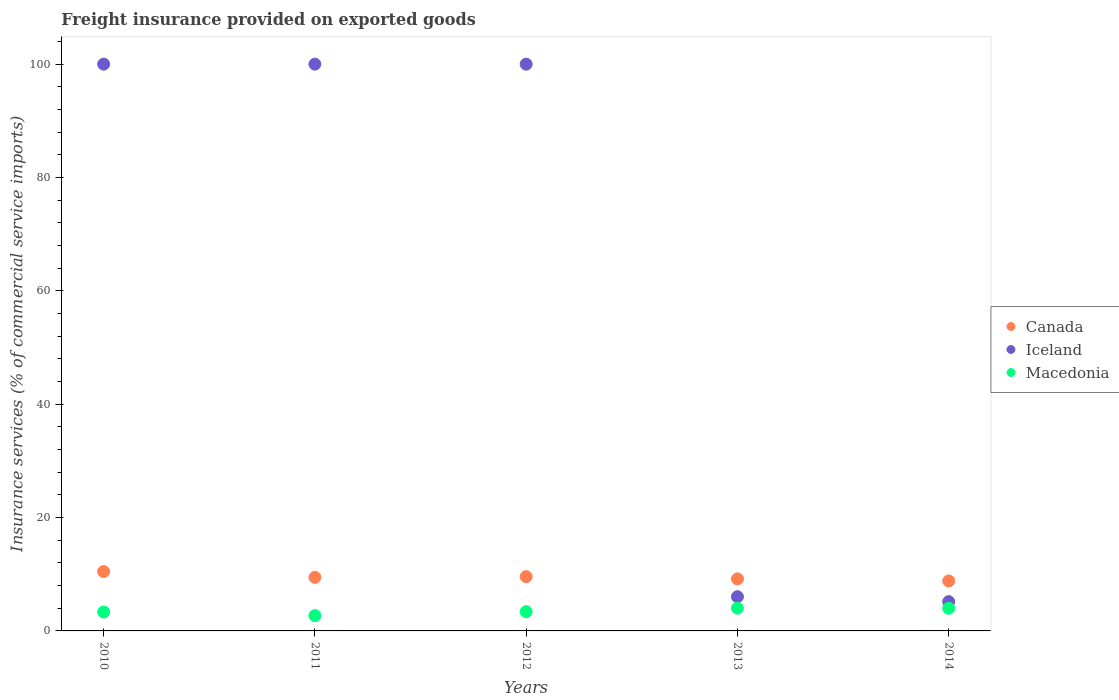What is the freight insurance provided on exported goods in Canada in 2013?
Your answer should be compact. 9.18. Across all years, what is the maximum freight insurance provided on exported goods in Iceland?
Give a very brief answer. 100. Across all years, what is the minimum freight insurance provided on exported goods in Canada?
Give a very brief answer. 8.82. In which year was the freight insurance provided on exported goods in Canada minimum?
Offer a very short reply. 2014. What is the total freight insurance provided on exported goods in Canada in the graph?
Ensure brevity in your answer.  47.5. What is the difference between the freight insurance provided on exported goods in Macedonia in 2012 and that in 2013?
Ensure brevity in your answer.  -0.62. What is the difference between the freight insurance provided on exported goods in Iceland in 2013 and the freight insurance provided on exported goods in Macedonia in 2014?
Give a very brief answer. 2.03. What is the average freight insurance provided on exported goods in Macedonia per year?
Ensure brevity in your answer.  3.49. In the year 2013, what is the difference between the freight insurance provided on exported goods in Canada and freight insurance provided on exported goods in Macedonia?
Ensure brevity in your answer.  5.17. What is the ratio of the freight insurance provided on exported goods in Macedonia in 2011 to that in 2012?
Make the answer very short. 0.79. Is the freight insurance provided on exported goods in Canada in 2011 less than that in 2013?
Keep it short and to the point. No. Is the difference between the freight insurance provided on exported goods in Canada in 2012 and 2013 greater than the difference between the freight insurance provided on exported goods in Macedonia in 2012 and 2013?
Make the answer very short. Yes. What is the difference between the highest and the second highest freight insurance provided on exported goods in Canada?
Your answer should be compact. 0.89. What is the difference between the highest and the lowest freight insurance provided on exported goods in Iceland?
Offer a terse response. 94.83. In how many years, is the freight insurance provided on exported goods in Macedonia greater than the average freight insurance provided on exported goods in Macedonia taken over all years?
Provide a short and direct response. 2. Is it the case that in every year, the sum of the freight insurance provided on exported goods in Iceland and freight insurance provided on exported goods in Canada  is greater than the freight insurance provided on exported goods in Macedonia?
Your answer should be very brief. Yes. Is the freight insurance provided on exported goods in Canada strictly less than the freight insurance provided on exported goods in Iceland over the years?
Offer a terse response. No. How many dotlines are there?
Provide a short and direct response. 3. Are the values on the major ticks of Y-axis written in scientific E-notation?
Your answer should be compact. No. What is the title of the graph?
Offer a very short reply. Freight insurance provided on exported goods. What is the label or title of the X-axis?
Offer a terse response. Years. What is the label or title of the Y-axis?
Your answer should be very brief. Insurance services (% of commercial service imports). What is the Insurance services (% of commercial service imports) of Canada in 2010?
Your response must be concise. 10.47. What is the Insurance services (% of commercial service imports) in Macedonia in 2010?
Your answer should be compact. 3.33. What is the Insurance services (% of commercial service imports) of Canada in 2011?
Offer a very short reply. 9.45. What is the Insurance services (% of commercial service imports) in Macedonia in 2011?
Your response must be concise. 2.7. What is the Insurance services (% of commercial service imports) in Canada in 2012?
Your response must be concise. 9.58. What is the Insurance services (% of commercial service imports) in Iceland in 2012?
Your answer should be compact. 100. What is the Insurance services (% of commercial service imports) of Macedonia in 2012?
Give a very brief answer. 3.4. What is the Insurance services (% of commercial service imports) in Canada in 2013?
Provide a succinct answer. 9.18. What is the Insurance services (% of commercial service imports) of Iceland in 2013?
Your response must be concise. 6.03. What is the Insurance services (% of commercial service imports) in Macedonia in 2013?
Keep it short and to the point. 4.02. What is the Insurance services (% of commercial service imports) in Canada in 2014?
Provide a succinct answer. 8.82. What is the Insurance services (% of commercial service imports) in Iceland in 2014?
Give a very brief answer. 5.17. What is the Insurance services (% of commercial service imports) in Macedonia in 2014?
Make the answer very short. 4.01. Across all years, what is the maximum Insurance services (% of commercial service imports) in Canada?
Your response must be concise. 10.47. Across all years, what is the maximum Insurance services (% of commercial service imports) of Iceland?
Provide a short and direct response. 100. Across all years, what is the maximum Insurance services (% of commercial service imports) of Macedonia?
Your answer should be very brief. 4.02. Across all years, what is the minimum Insurance services (% of commercial service imports) of Canada?
Keep it short and to the point. 8.82. Across all years, what is the minimum Insurance services (% of commercial service imports) of Iceland?
Provide a short and direct response. 5.17. Across all years, what is the minimum Insurance services (% of commercial service imports) in Macedonia?
Provide a succinct answer. 2.7. What is the total Insurance services (% of commercial service imports) in Canada in the graph?
Give a very brief answer. 47.5. What is the total Insurance services (% of commercial service imports) in Iceland in the graph?
Your response must be concise. 311.2. What is the total Insurance services (% of commercial service imports) of Macedonia in the graph?
Make the answer very short. 17.45. What is the difference between the Insurance services (% of commercial service imports) of Canada in 2010 and that in 2011?
Offer a terse response. 1.02. What is the difference between the Insurance services (% of commercial service imports) in Macedonia in 2010 and that in 2011?
Keep it short and to the point. 0.64. What is the difference between the Insurance services (% of commercial service imports) in Canada in 2010 and that in 2012?
Your answer should be very brief. 0.89. What is the difference between the Insurance services (% of commercial service imports) of Iceland in 2010 and that in 2012?
Offer a very short reply. 0. What is the difference between the Insurance services (% of commercial service imports) in Macedonia in 2010 and that in 2012?
Offer a very short reply. -0.06. What is the difference between the Insurance services (% of commercial service imports) in Canada in 2010 and that in 2013?
Ensure brevity in your answer.  1.29. What is the difference between the Insurance services (% of commercial service imports) of Iceland in 2010 and that in 2013?
Your answer should be compact. 93.97. What is the difference between the Insurance services (% of commercial service imports) in Macedonia in 2010 and that in 2013?
Offer a terse response. -0.68. What is the difference between the Insurance services (% of commercial service imports) in Canada in 2010 and that in 2014?
Offer a terse response. 1.65. What is the difference between the Insurance services (% of commercial service imports) in Iceland in 2010 and that in 2014?
Offer a terse response. 94.83. What is the difference between the Insurance services (% of commercial service imports) in Macedonia in 2010 and that in 2014?
Your answer should be very brief. -0.67. What is the difference between the Insurance services (% of commercial service imports) in Canada in 2011 and that in 2012?
Your answer should be compact. -0.13. What is the difference between the Insurance services (% of commercial service imports) of Macedonia in 2011 and that in 2012?
Keep it short and to the point. -0.7. What is the difference between the Insurance services (% of commercial service imports) in Canada in 2011 and that in 2013?
Offer a very short reply. 0.27. What is the difference between the Insurance services (% of commercial service imports) in Iceland in 2011 and that in 2013?
Provide a short and direct response. 93.97. What is the difference between the Insurance services (% of commercial service imports) in Macedonia in 2011 and that in 2013?
Keep it short and to the point. -1.32. What is the difference between the Insurance services (% of commercial service imports) of Canada in 2011 and that in 2014?
Offer a terse response. 0.63. What is the difference between the Insurance services (% of commercial service imports) in Iceland in 2011 and that in 2014?
Your response must be concise. 94.83. What is the difference between the Insurance services (% of commercial service imports) in Macedonia in 2011 and that in 2014?
Provide a succinct answer. -1.31. What is the difference between the Insurance services (% of commercial service imports) in Canada in 2012 and that in 2013?
Offer a terse response. 0.4. What is the difference between the Insurance services (% of commercial service imports) of Iceland in 2012 and that in 2013?
Your answer should be compact. 93.97. What is the difference between the Insurance services (% of commercial service imports) of Macedonia in 2012 and that in 2013?
Keep it short and to the point. -0.62. What is the difference between the Insurance services (% of commercial service imports) of Canada in 2012 and that in 2014?
Make the answer very short. 0.77. What is the difference between the Insurance services (% of commercial service imports) in Iceland in 2012 and that in 2014?
Make the answer very short. 94.83. What is the difference between the Insurance services (% of commercial service imports) in Macedonia in 2012 and that in 2014?
Make the answer very short. -0.61. What is the difference between the Insurance services (% of commercial service imports) in Canada in 2013 and that in 2014?
Keep it short and to the point. 0.37. What is the difference between the Insurance services (% of commercial service imports) of Iceland in 2013 and that in 2014?
Provide a short and direct response. 0.86. What is the difference between the Insurance services (% of commercial service imports) of Macedonia in 2013 and that in 2014?
Give a very brief answer. 0.01. What is the difference between the Insurance services (% of commercial service imports) in Canada in 2010 and the Insurance services (% of commercial service imports) in Iceland in 2011?
Keep it short and to the point. -89.53. What is the difference between the Insurance services (% of commercial service imports) of Canada in 2010 and the Insurance services (% of commercial service imports) of Macedonia in 2011?
Your answer should be very brief. 7.77. What is the difference between the Insurance services (% of commercial service imports) in Iceland in 2010 and the Insurance services (% of commercial service imports) in Macedonia in 2011?
Offer a very short reply. 97.3. What is the difference between the Insurance services (% of commercial service imports) of Canada in 2010 and the Insurance services (% of commercial service imports) of Iceland in 2012?
Provide a short and direct response. -89.53. What is the difference between the Insurance services (% of commercial service imports) in Canada in 2010 and the Insurance services (% of commercial service imports) in Macedonia in 2012?
Ensure brevity in your answer.  7.07. What is the difference between the Insurance services (% of commercial service imports) in Iceland in 2010 and the Insurance services (% of commercial service imports) in Macedonia in 2012?
Make the answer very short. 96.6. What is the difference between the Insurance services (% of commercial service imports) of Canada in 2010 and the Insurance services (% of commercial service imports) of Iceland in 2013?
Provide a succinct answer. 4.44. What is the difference between the Insurance services (% of commercial service imports) of Canada in 2010 and the Insurance services (% of commercial service imports) of Macedonia in 2013?
Offer a very short reply. 6.45. What is the difference between the Insurance services (% of commercial service imports) of Iceland in 2010 and the Insurance services (% of commercial service imports) of Macedonia in 2013?
Make the answer very short. 95.98. What is the difference between the Insurance services (% of commercial service imports) of Canada in 2010 and the Insurance services (% of commercial service imports) of Iceland in 2014?
Offer a very short reply. 5.3. What is the difference between the Insurance services (% of commercial service imports) in Canada in 2010 and the Insurance services (% of commercial service imports) in Macedonia in 2014?
Ensure brevity in your answer.  6.46. What is the difference between the Insurance services (% of commercial service imports) in Iceland in 2010 and the Insurance services (% of commercial service imports) in Macedonia in 2014?
Your response must be concise. 95.99. What is the difference between the Insurance services (% of commercial service imports) of Canada in 2011 and the Insurance services (% of commercial service imports) of Iceland in 2012?
Your answer should be very brief. -90.55. What is the difference between the Insurance services (% of commercial service imports) in Canada in 2011 and the Insurance services (% of commercial service imports) in Macedonia in 2012?
Your answer should be very brief. 6.05. What is the difference between the Insurance services (% of commercial service imports) of Iceland in 2011 and the Insurance services (% of commercial service imports) of Macedonia in 2012?
Give a very brief answer. 96.6. What is the difference between the Insurance services (% of commercial service imports) of Canada in 2011 and the Insurance services (% of commercial service imports) of Iceland in 2013?
Give a very brief answer. 3.42. What is the difference between the Insurance services (% of commercial service imports) of Canada in 2011 and the Insurance services (% of commercial service imports) of Macedonia in 2013?
Your answer should be compact. 5.43. What is the difference between the Insurance services (% of commercial service imports) of Iceland in 2011 and the Insurance services (% of commercial service imports) of Macedonia in 2013?
Keep it short and to the point. 95.98. What is the difference between the Insurance services (% of commercial service imports) of Canada in 2011 and the Insurance services (% of commercial service imports) of Iceland in 2014?
Offer a very short reply. 4.28. What is the difference between the Insurance services (% of commercial service imports) in Canada in 2011 and the Insurance services (% of commercial service imports) in Macedonia in 2014?
Ensure brevity in your answer.  5.44. What is the difference between the Insurance services (% of commercial service imports) in Iceland in 2011 and the Insurance services (% of commercial service imports) in Macedonia in 2014?
Provide a succinct answer. 95.99. What is the difference between the Insurance services (% of commercial service imports) in Canada in 2012 and the Insurance services (% of commercial service imports) in Iceland in 2013?
Ensure brevity in your answer.  3.55. What is the difference between the Insurance services (% of commercial service imports) in Canada in 2012 and the Insurance services (% of commercial service imports) in Macedonia in 2013?
Your response must be concise. 5.57. What is the difference between the Insurance services (% of commercial service imports) of Iceland in 2012 and the Insurance services (% of commercial service imports) of Macedonia in 2013?
Keep it short and to the point. 95.98. What is the difference between the Insurance services (% of commercial service imports) in Canada in 2012 and the Insurance services (% of commercial service imports) in Iceland in 2014?
Your response must be concise. 4.41. What is the difference between the Insurance services (% of commercial service imports) in Canada in 2012 and the Insurance services (% of commercial service imports) in Macedonia in 2014?
Ensure brevity in your answer.  5.58. What is the difference between the Insurance services (% of commercial service imports) in Iceland in 2012 and the Insurance services (% of commercial service imports) in Macedonia in 2014?
Offer a very short reply. 95.99. What is the difference between the Insurance services (% of commercial service imports) in Canada in 2013 and the Insurance services (% of commercial service imports) in Iceland in 2014?
Your response must be concise. 4.01. What is the difference between the Insurance services (% of commercial service imports) in Canada in 2013 and the Insurance services (% of commercial service imports) in Macedonia in 2014?
Your answer should be very brief. 5.18. What is the difference between the Insurance services (% of commercial service imports) of Iceland in 2013 and the Insurance services (% of commercial service imports) of Macedonia in 2014?
Offer a very short reply. 2.03. What is the average Insurance services (% of commercial service imports) of Canada per year?
Keep it short and to the point. 9.5. What is the average Insurance services (% of commercial service imports) of Iceland per year?
Make the answer very short. 62.24. What is the average Insurance services (% of commercial service imports) in Macedonia per year?
Provide a succinct answer. 3.49. In the year 2010, what is the difference between the Insurance services (% of commercial service imports) in Canada and Insurance services (% of commercial service imports) in Iceland?
Your answer should be compact. -89.53. In the year 2010, what is the difference between the Insurance services (% of commercial service imports) of Canada and Insurance services (% of commercial service imports) of Macedonia?
Give a very brief answer. 7.14. In the year 2010, what is the difference between the Insurance services (% of commercial service imports) in Iceland and Insurance services (% of commercial service imports) in Macedonia?
Your answer should be compact. 96.67. In the year 2011, what is the difference between the Insurance services (% of commercial service imports) of Canada and Insurance services (% of commercial service imports) of Iceland?
Your answer should be compact. -90.55. In the year 2011, what is the difference between the Insurance services (% of commercial service imports) of Canada and Insurance services (% of commercial service imports) of Macedonia?
Your response must be concise. 6.75. In the year 2011, what is the difference between the Insurance services (% of commercial service imports) of Iceland and Insurance services (% of commercial service imports) of Macedonia?
Ensure brevity in your answer.  97.3. In the year 2012, what is the difference between the Insurance services (% of commercial service imports) of Canada and Insurance services (% of commercial service imports) of Iceland?
Your answer should be very brief. -90.42. In the year 2012, what is the difference between the Insurance services (% of commercial service imports) of Canada and Insurance services (% of commercial service imports) of Macedonia?
Keep it short and to the point. 6.18. In the year 2012, what is the difference between the Insurance services (% of commercial service imports) in Iceland and Insurance services (% of commercial service imports) in Macedonia?
Your answer should be compact. 96.6. In the year 2013, what is the difference between the Insurance services (% of commercial service imports) of Canada and Insurance services (% of commercial service imports) of Iceland?
Provide a short and direct response. 3.15. In the year 2013, what is the difference between the Insurance services (% of commercial service imports) of Canada and Insurance services (% of commercial service imports) of Macedonia?
Offer a very short reply. 5.17. In the year 2013, what is the difference between the Insurance services (% of commercial service imports) of Iceland and Insurance services (% of commercial service imports) of Macedonia?
Provide a succinct answer. 2.02. In the year 2014, what is the difference between the Insurance services (% of commercial service imports) of Canada and Insurance services (% of commercial service imports) of Iceland?
Make the answer very short. 3.65. In the year 2014, what is the difference between the Insurance services (% of commercial service imports) of Canada and Insurance services (% of commercial service imports) of Macedonia?
Offer a terse response. 4.81. In the year 2014, what is the difference between the Insurance services (% of commercial service imports) in Iceland and Insurance services (% of commercial service imports) in Macedonia?
Provide a succinct answer. 1.16. What is the ratio of the Insurance services (% of commercial service imports) in Canada in 2010 to that in 2011?
Give a very brief answer. 1.11. What is the ratio of the Insurance services (% of commercial service imports) of Macedonia in 2010 to that in 2011?
Make the answer very short. 1.24. What is the ratio of the Insurance services (% of commercial service imports) of Canada in 2010 to that in 2012?
Your answer should be compact. 1.09. What is the ratio of the Insurance services (% of commercial service imports) of Macedonia in 2010 to that in 2012?
Provide a short and direct response. 0.98. What is the ratio of the Insurance services (% of commercial service imports) in Canada in 2010 to that in 2013?
Your response must be concise. 1.14. What is the ratio of the Insurance services (% of commercial service imports) of Iceland in 2010 to that in 2013?
Offer a terse response. 16.58. What is the ratio of the Insurance services (% of commercial service imports) in Macedonia in 2010 to that in 2013?
Ensure brevity in your answer.  0.83. What is the ratio of the Insurance services (% of commercial service imports) of Canada in 2010 to that in 2014?
Your response must be concise. 1.19. What is the ratio of the Insurance services (% of commercial service imports) of Iceland in 2010 to that in 2014?
Keep it short and to the point. 19.35. What is the ratio of the Insurance services (% of commercial service imports) in Macedonia in 2010 to that in 2014?
Provide a succinct answer. 0.83. What is the ratio of the Insurance services (% of commercial service imports) of Canada in 2011 to that in 2012?
Ensure brevity in your answer.  0.99. What is the ratio of the Insurance services (% of commercial service imports) in Iceland in 2011 to that in 2012?
Your answer should be compact. 1. What is the ratio of the Insurance services (% of commercial service imports) of Macedonia in 2011 to that in 2012?
Your answer should be compact. 0.79. What is the ratio of the Insurance services (% of commercial service imports) of Canada in 2011 to that in 2013?
Your answer should be very brief. 1.03. What is the ratio of the Insurance services (% of commercial service imports) of Iceland in 2011 to that in 2013?
Your response must be concise. 16.58. What is the ratio of the Insurance services (% of commercial service imports) of Macedonia in 2011 to that in 2013?
Your response must be concise. 0.67. What is the ratio of the Insurance services (% of commercial service imports) of Canada in 2011 to that in 2014?
Your answer should be compact. 1.07. What is the ratio of the Insurance services (% of commercial service imports) in Iceland in 2011 to that in 2014?
Provide a short and direct response. 19.35. What is the ratio of the Insurance services (% of commercial service imports) of Macedonia in 2011 to that in 2014?
Your answer should be very brief. 0.67. What is the ratio of the Insurance services (% of commercial service imports) of Canada in 2012 to that in 2013?
Your answer should be compact. 1.04. What is the ratio of the Insurance services (% of commercial service imports) of Iceland in 2012 to that in 2013?
Provide a short and direct response. 16.58. What is the ratio of the Insurance services (% of commercial service imports) of Macedonia in 2012 to that in 2013?
Give a very brief answer. 0.85. What is the ratio of the Insurance services (% of commercial service imports) of Canada in 2012 to that in 2014?
Your answer should be very brief. 1.09. What is the ratio of the Insurance services (% of commercial service imports) of Iceland in 2012 to that in 2014?
Keep it short and to the point. 19.35. What is the ratio of the Insurance services (% of commercial service imports) in Macedonia in 2012 to that in 2014?
Your response must be concise. 0.85. What is the ratio of the Insurance services (% of commercial service imports) of Canada in 2013 to that in 2014?
Make the answer very short. 1.04. What is the ratio of the Insurance services (% of commercial service imports) in Iceland in 2013 to that in 2014?
Keep it short and to the point. 1.17. What is the ratio of the Insurance services (% of commercial service imports) in Macedonia in 2013 to that in 2014?
Provide a succinct answer. 1. What is the difference between the highest and the second highest Insurance services (% of commercial service imports) of Canada?
Ensure brevity in your answer.  0.89. What is the difference between the highest and the second highest Insurance services (% of commercial service imports) in Macedonia?
Offer a terse response. 0.01. What is the difference between the highest and the lowest Insurance services (% of commercial service imports) in Canada?
Your response must be concise. 1.65. What is the difference between the highest and the lowest Insurance services (% of commercial service imports) in Iceland?
Your answer should be compact. 94.83. What is the difference between the highest and the lowest Insurance services (% of commercial service imports) of Macedonia?
Provide a short and direct response. 1.32. 